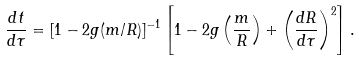Convert formula to latex. <formula><loc_0><loc_0><loc_500><loc_500>\frac { d t } { d \tau } = [ 1 - 2 g ( m / R ) ] ^ { - 1 } \left [ 1 - 2 g \left ( \frac { m } { R } \right ) + \left ( \frac { d R } { d \tau } \right ) ^ { 2 } \right ] .</formula> 